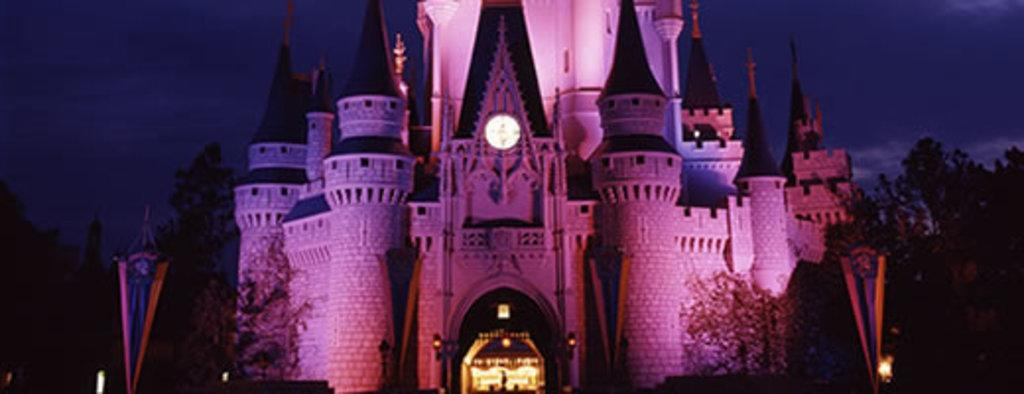What is the main structure in the center of the image? There is a building in the center of the image. What type of vegetation is on the right side of the image? There are trees on the right side of the image. What is visible at the top of the image? The sky is visible at the top of the image. What subject is being taught in the image? There is no indication of teaching or a classroom setting in the image. 